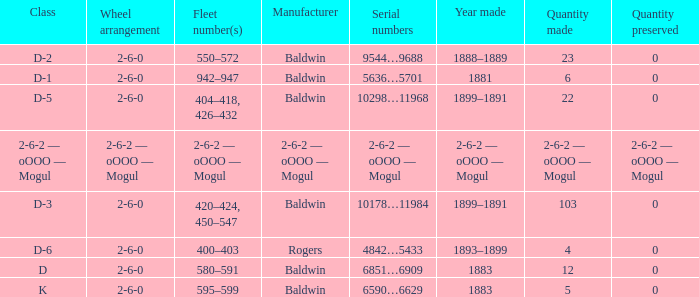What is the quantity made when the wheel arrangement is 2-6-0 and the class is k? 5.0. 